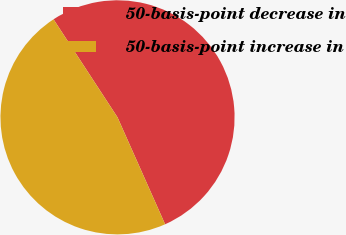Convert chart. <chart><loc_0><loc_0><loc_500><loc_500><pie_chart><fcel>50-basis-point decrease in<fcel>50-basis-point increase in<nl><fcel>52.54%<fcel>47.46%<nl></chart> 